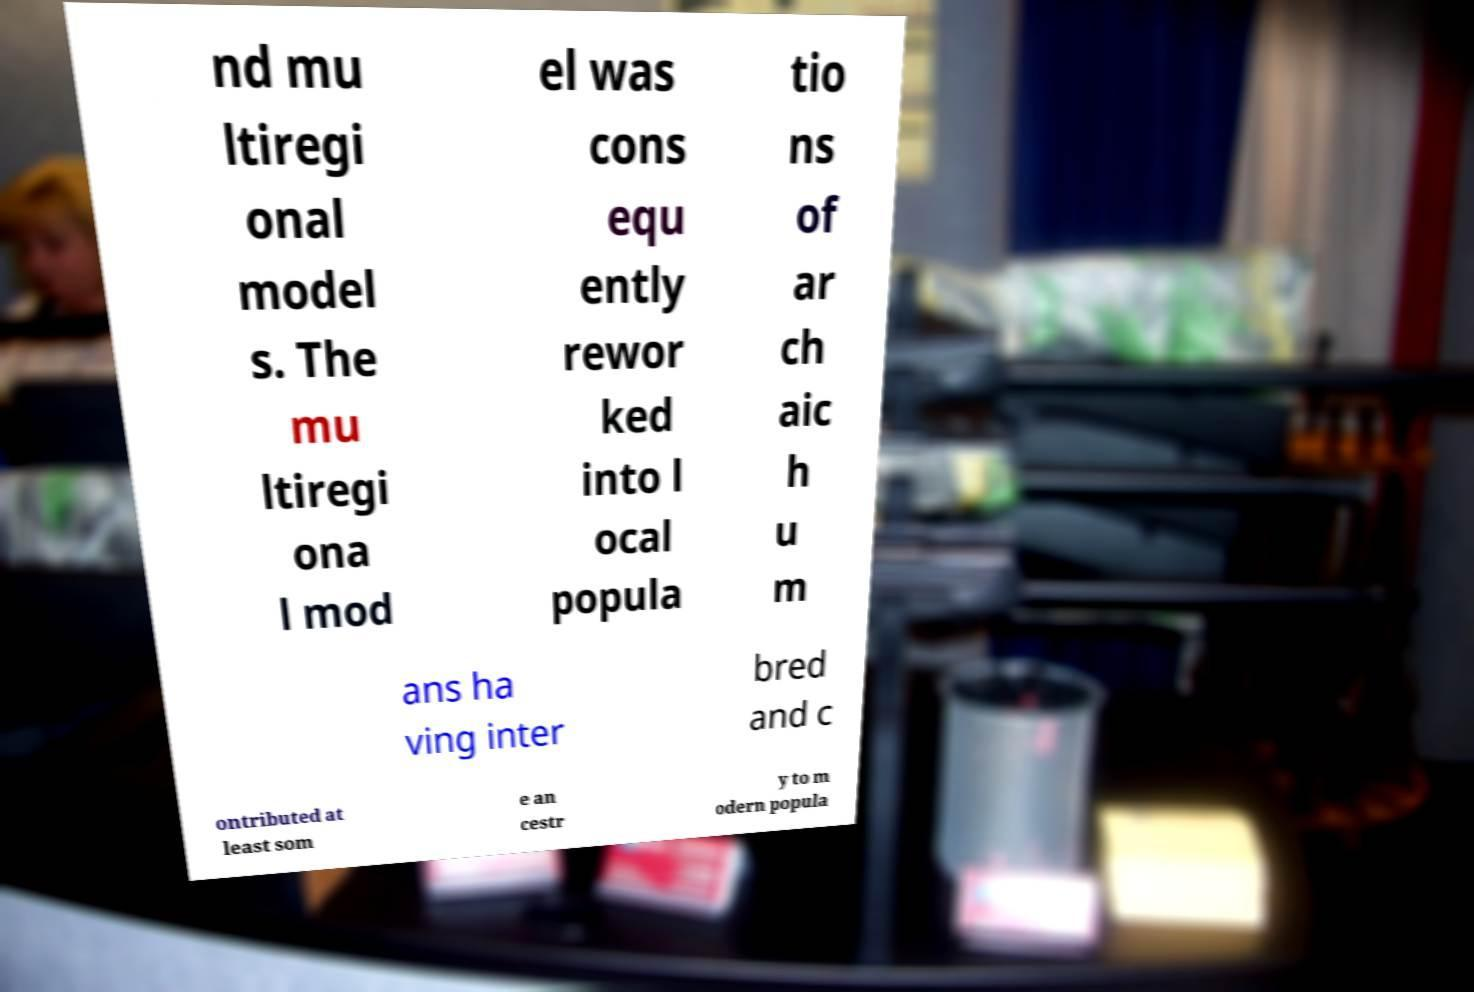Could you extract and type out the text from this image? nd mu ltiregi onal model s. The mu ltiregi ona l mod el was cons equ ently rewor ked into l ocal popula tio ns of ar ch aic h u m ans ha ving inter bred and c ontributed at least som e an cestr y to m odern popula 